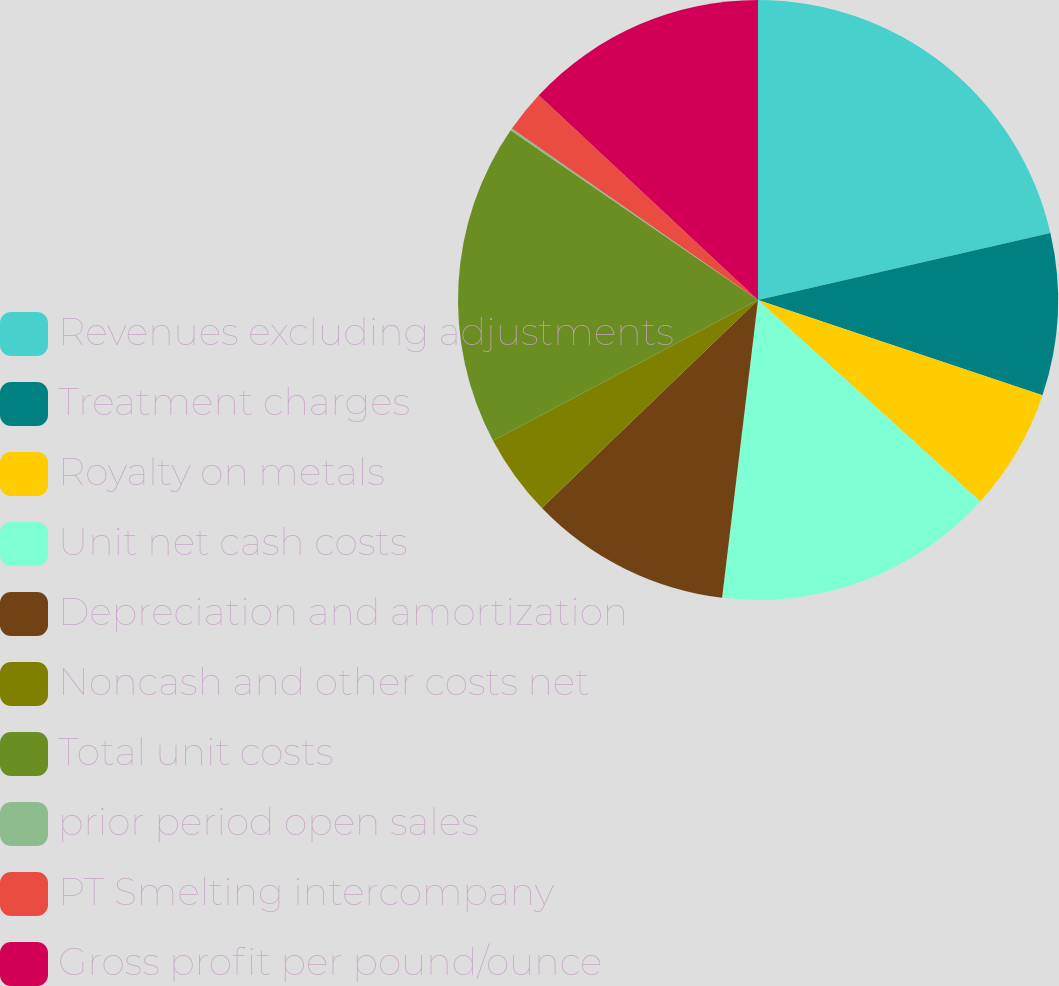<chart> <loc_0><loc_0><loc_500><loc_500><pie_chart><fcel>Revenues excluding adjustments<fcel>Treatment charges<fcel>Royalty on metals<fcel>Unit net cash costs<fcel>Depreciation and amortization<fcel>Noncash and other costs net<fcel>Total unit costs<fcel>prior period open sales<fcel>PT Smelting intercompany<fcel>Gross profit per pound/ounce<nl><fcel>21.41%<fcel>8.73%<fcel>6.58%<fcel>15.19%<fcel>10.89%<fcel>4.43%<fcel>17.34%<fcel>0.12%<fcel>2.27%<fcel>13.04%<nl></chart> 